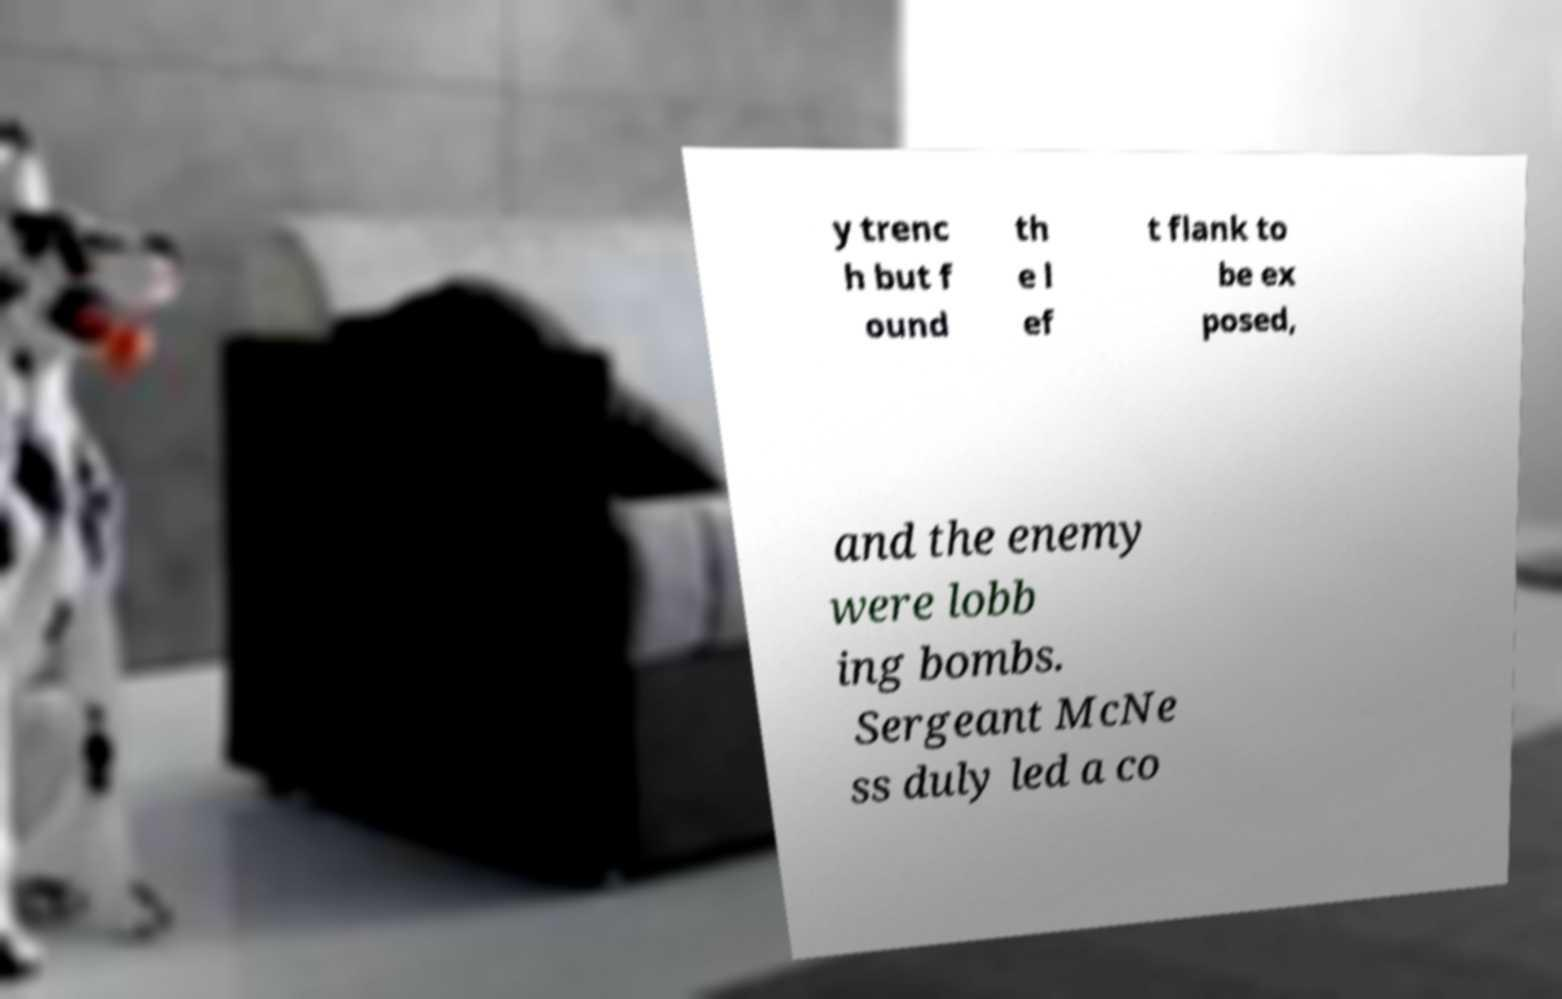Can you accurately transcribe the text from the provided image for me? y trenc h but f ound th e l ef t flank to be ex posed, and the enemy were lobb ing bombs. Sergeant McNe ss duly led a co 